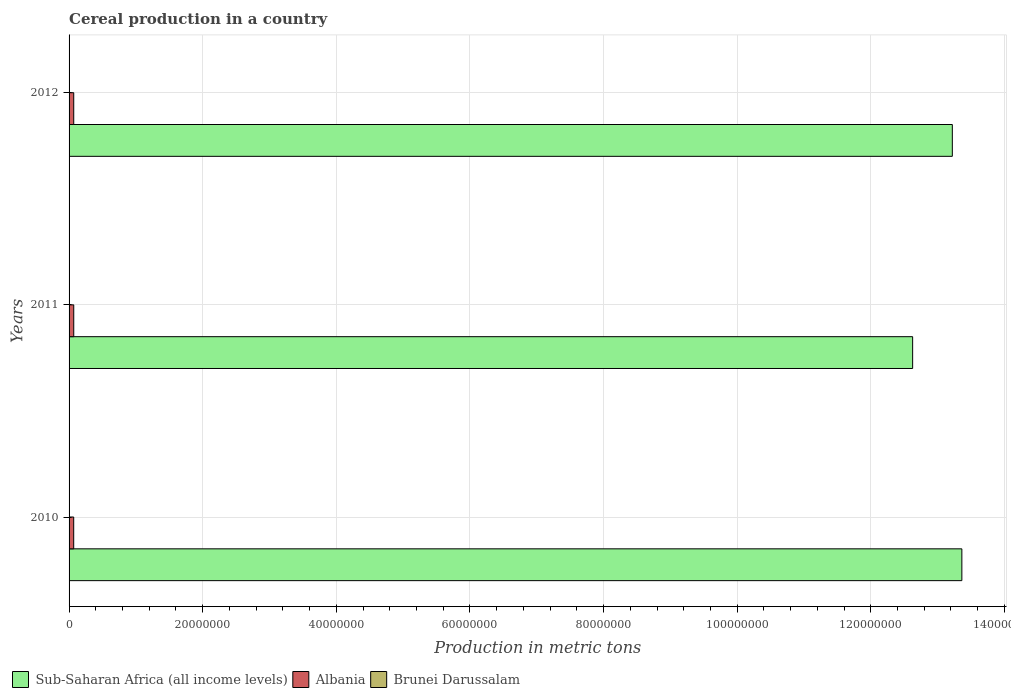How many different coloured bars are there?
Provide a succinct answer. 3. How many groups of bars are there?
Provide a succinct answer. 3. Are the number of bars per tick equal to the number of legend labels?
Make the answer very short. Yes. Are the number of bars on each tick of the Y-axis equal?
Make the answer very short. Yes. In how many cases, is the number of bars for a given year not equal to the number of legend labels?
Keep it short and to the point. 0. What is the total cereal production in Sub-Saharan Africa (all income levels) in 2012?
Give a very brief answer. 1.32e+08. Across all years, what is the maximum total cereal production in Sub-Saharan Africa (all income levels)?
Ensure brevity in your answer.  1.34e+08. Across all years, what is the minimum total cereal production in Brunei Darussalam?
Your answer should be very brief. 1072. In which year was the total cereal production in Albania minimum?
Keep it short and to the point. 2010. What is the total total cereal production in Albania in the graph?
Provide a succinct answer. 2.09e+06. What is the difference between the total cereal production in Sub-Saharan Africa (all income levels) in 2010 and that in 2011?
Make the answer very short. 7.37e+06. What is the difference between the total cereal production in Albania in 2010 and the total cereal production in Brunei Darussalam in 2012?
Your answer should be very brief. 6.92e+05. What is the average total cereal production in Albania per year?
Your response must be concise. 6.97e+05. In the year 2011, what is the difference between the total cereal production in Albania and total cereal production in Brunei Darussalam?
Offer a terse response. 7.00e+05. What is the ratio of the total cereal production in Albania in 2010 to that in 2011?
Your answer should be compact. 0.99. Is the total cereal production in Sub-Saharan Africa (all income levels) in 2011 less than that in 2012?
Provide a succinct answer. Yes. What is the difference between the highest and the second highest total cereal production in Sub-Saharan Africa (all income levels)?
Make the answer very short. 1.43e+06. What is the difference between the highest and the lowest total cereal production in Sub-Saharan Africa (all income levels)?
Your answer should be very brief. 7.37e+06. In how many years, is the total cereal production in Sub-Saharan Africa (all income levels) greater than the average total cereal production in Sub-Saharan Africa (all income levels) taken over all years?
Your response must be concise. 2. What does the 2nd bar from the top in 2010 represents?
Offer a terse response. Albania. What does the 1st bar from the bottom in 2012 represents?
Offer a terse response. Sub-Saharan Africa (all income levels). Are all the bars in the graph horizontal?
Make the answer very short. Yes. What is the difference between two consecutive major ticks on the X-axis?
Your response must be concise. 2.00e+07. What is the title of the graph?
Offer a terse response. Cereal production in a country. Does "Central Europe" appear as one of the legend labels in the graph?
Offer a terse response. No. What is the label or title of the X-axis?
Your response must be concise. Production in metric tons. What is the Production in metric tons of Sub-Saharan Africa (all income levels) in 2010?
Your answer should be compact. 1.34e+08. What is the Production in metric tons in Albania in 2010?
Provide a succinct answer. 6.94e+05. What is the Production in metric tons of Brunei Darussalam in 2010?
Offer a terse response. 1072. What is the Production in metric tons in Sub-Saharan Africa (all income levels) in 2011?
Your response must be concise. 1.26e+08. What is the Production in metric tons of Albania in 2011?
Make the answer very short. 7.01e+05. What is the Production in metric tons of Brunei Darussalam in 2011?
Your answer should be very brief. 1480. What is the Production in metric tons of Sub-Saharan Africa (all income levels) in 2012?
Offer a terse response. 1.32e+08. What is the Production in metric tons of Albania in 2012?
Your answer should be very brief. 6.97e+05. What is the Production in metric tons of Brunei Darussalam in 2012?
Provide a succinct answer. 1756. Across all years, what is the maximum Production in metric tons in Sub-Saharan Africa (all income levels)?
Keep it short and to the point. 1.34e+08. Across all years, what is the maximum Production in metric tons of Albania?
Provide a short and direct response. 7.01e+05. Across all years, what is the maximum Production in metric tons in Brunei Darussalam?
Offer a terse response. 1756. Across all years, what is the minimum Production in metric tons in Sub-Saharan Africa (all income levels)?
Your response must be concise. 1.26e+08. Across all years, what is the minimum Production in metric tons of Albania?
Your answer should be compact. 6.94e+05. Across all years, what is the minimum Production in metric tons in Brunei Darussalam?
Make the answer very short. 1072. What is the total Production in metric tons of Sub-Saharan Africa (all income levels) in the graph?
Keep it short and to the point. 3.92e+08. What is the total Production in metric tons of Albania in the graph?
Ensure brevity in your answer.  2.09e+06. What is the total Production in metric tons of Brunei Darussalam in the graph?
Your answer should be very brief. 4308. What is the difference between the Production in metric tons of Sub-Saharan Africa (all income levels) in 2010 and that in 2011?
Your response must be concise. 7.37e+06. What is the difference between the Production in metric tons in Albania in 2010 and that in 2011?
Offer a terse response. -7400. What is the difference between the Production in metric tons of Brunei Darussalam in 2010 and that in 2011?
Ensure brevity in your answer.  -408. What is the difference between the Production in metric tons in Sub-Saharan Africa (all income levels) in 2010 and that in 2012?
Provide a short and direct response. 1.43e+06. What is the difference between the Production in metric tons of Albania in 2010 and that in 2012?
Your response must be concise. -3600. What is the difference between the Production in metric tons in Brunei Darussalam in 2010 and that in 2012?
Give a very brief answer. -684. What is the difference between the Production in metric tons of Sub-Saharan Africa (all income levels) in 2011 and that in 2012?
Offer a very short reply. -5.94e+06. What is the difference between the Production in metric tons in Albania in 2011 and that in 2012?
Keep it short and to the point. 3800. What is the difference between the Production in metric tons of Brunei Darussalam in 2011 and that in 2012?
Provide a short and direct response. -276. What is the difference between the Production in metric tons in Sub-Saharan Africa (all income levels) in 2010 and the Production in metric tons in Albania in 2011?
Make the answer very short. 1.33e+08. What is the difference between the Production in metric tons in Sub-Saharan Africa (all income levels) in 2010 and the Production in metric tons in Brunei Darussalam in 2011?
Provide a succinct answer. 1.34e+08. What is the difference between the Production in metric tons in Albania in 2010 and the Production in metric tons in Brunei Darussalam in 2011?
Ensure brevity in your answer.  6.92e+05. What is the difference between the Production in metric tons of Sub-Saharan Africa (all income levels) in 2010 and the Production in metric tons of Albania in 2012?
Your answer should be compact. 1.33e+08. What is the difference between the Production in metric tons of Sub-Saharan Africa (all income levels) in 2010 and the Production in metric tons of Brunei Darussalam in 2012?
Offer a terse response. 1.34e+08. What is the difference between the Production in metric tons of Albania in 2010 and the Production in metric tons of Brunei Darussalam in 2012?
Your answer should be compact. 6.92e+05. What is the difference between the Production in metric tons of Sub-Saharan Africa (all income levels) in 2011 and the Production in metric tons of Albania in 2012?
Ensure brevity in your answer.  1.26e+08. What is the difference between the Production in metric tons in Sub-Saharan Africa (all income levels) in 2011 and the Production in metric tons in Brunei Darussalam in 2012?
Ensure brevity in your answer.  1.26e+08. What is the difference between the Production in metric tons in Albania in 2011 and the Production in metric tons in Brunei Darussalam in 2012?
Keep it short and to the point. 6.99e+05. What is the average Production in metric tons in Sub-Saharan Africa (all income levels) per year?
Your answer should be very brief. 1.31e+08. What is the average Production in metric tons in Albania per year?
Keep it short and to the point. 6.97e+05. What is the average Production in metric tons of Brunei Darussalam per year?
Give a very brief answer. 1436. In the year 2010, what is the difference between the Production in metric tons in Sub-Saharan Africa (all income levels) and Production in metric tons in Albania?
Provide a succinct answer. 1.33e+08. In the year 2010, what is the difference between the Production in metric tons of Sub-Saharan Africa (all income levels) and Production in metric tons of Brunei Darussalam?
Give a very brief answer. 1.34e+08. In the year 2010, what is the difference between the Production in metric tons in Albania and Production in metric tons in Brunei Darussalam?
Your response must be concise. 6.93e+05. In the year 2011, what is the difference between the Production in metric tons of Sub-Saharan Africa (all income levels) and Production in metric tons of Albania?
Offer a terse response. 1.26e+08. In the year 2011, what is the difference between the Production in metric tons of Sub-Saharan Africa (all income levels) and Production in metric tons of Brunei Darussalam?
Your answer should be very brief. 1.26e+08. In the year 2011, what is the difference between the Production in metric tons in Albania and Production in metric tons in Brunei Darussalam?
Offer a terse response. 7.00e+05. In the year 2012, what is the difference between the Production in metric tons of Sub-Saharan Africa (all income levels) and Production in metric tons of Albania?
Ensure brevity in your answer.  1.32e+08. In the year 2012, what is the difference between the Production in metric tons in Sub-Saharan Africa (all income levels) and Production in metric tons in Brunei Darussalam?
Keep it short and to the point. 1.32e+08. In the year 2012, what is the difference between the Production in metric tons of Albania and Production in metric tons of Brunei Darussalam?
Your answer should be very brief. 6.96e+05. What is the ratio of the Production in metric tons in Sub-Saharan Africa (all income levels) in 2010 to that in 2011?
Offer a very short reply. 1.06. What is the ratio of the Production in metric tons of Brunei Darussalam in 2010 to that in 2011?
Provide a succinct answer. 0.72. What is the ratio of the Production in metric tons in Sub-Saharan Africa (all income levels) in 2010 to that in 2012?
Provide a succinct answer. 1.01. What is the ratio of the Production in metric tons of Albania in 2010 to that in 2012?
Provide a short and direct response. 0.99. What is the ratio of the Production in metric tons in Brunei Darussalam in 2010 to that in 2012?
Provide a succinct answer. 0.61. What is the ratio of the Production in metric tons in Sub-Saharan Africa (all income levels) in 2011 to that in 2012?
Offer a very short reply. 0.96. What is the ratio of the Production in metric tons in Albania in 2011 to that in 2012?
Keep it short and to the point. 1.01. What is the ratio of the Production in metric tons in Brunei Darussalam in 2011 to that in 2012?
Your answer should be very brief. 0.84. What is the difference between the highest and the second highest Production in metric tons in Sub-Saharan Africa (all income levels)?
Your answer should be compact. 1.43e+06. What is the difference between the highest and the second highest Production in metric tons in Albania?
Ensure brevity in your answer.  3800. What is the difference between the highest and the second highest Production in metric tons of Brunei Darussalam?
Provide a short and direct response. 276. What is the difference between the highest and the lowest Production in metric tons of Sub-Saharan Africa (all income levels)?
Keep it short and to the point. 7.37e+06. What is the difference between the highest and the lowest Production in metric tons in Albania?
Offer a terse response. 7400. What is the difference between the highest and the lowest Production in metric tons of Brunei Darussalam?
Offer a very short reply. 684. 